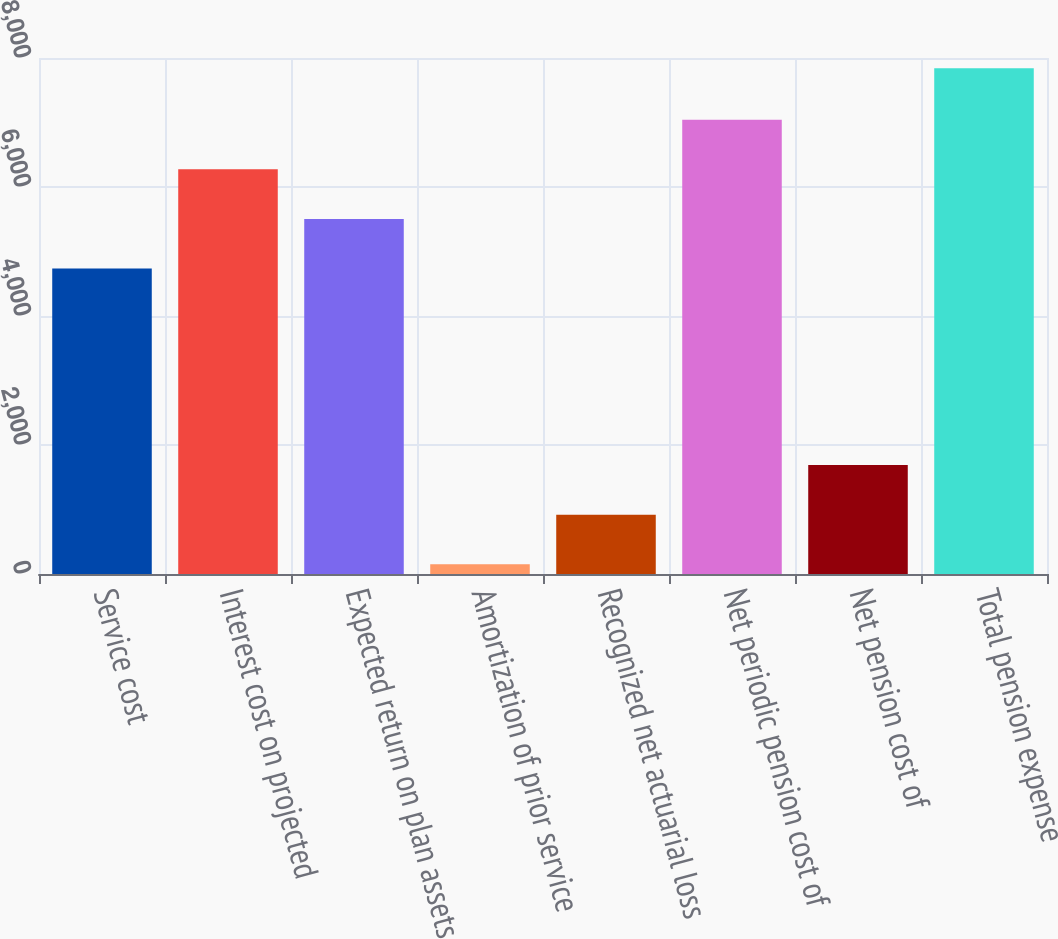<chart> <loc_0><loc_0><loc_500><loc_500><bar_chart><fcel>Service cost<fcel>Interest cost on projected<fcel>Expected return on plan assets<fcel>Amortization of prior service<fcel>Recognized net actuarial loss<fcel>Net periodic pension cost of<fcel>Net pension cost of<fcel>Total pension expense<nl><fcel>4735<fcel>6273.4<fcel>5504.2<fcel>150<fcel>919.2<fcel>7042.6<fcel>1688.4<fcel>7842<nl></chart> 